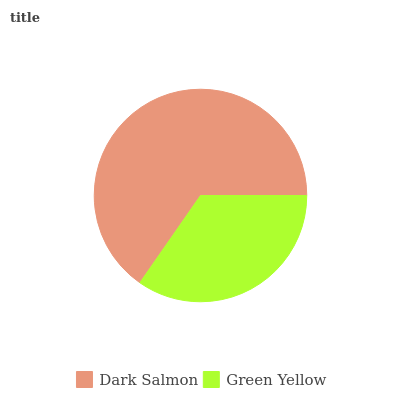Is Green Yellow the minimum?
Answer yes or no. Yes. Is Dark Salmon the maximum?
Answer yes or no. Yes. Is Green Yellow the maximum?
Answer yes or no. No. Is Dark Salmon greater than Green Yellow?
Answer yes or no. Yes. Is Green Yellow less than Dark Salmon?
Answer yes or no. Yes. Is Green Yellow greater than Dark Salmon?
Answer yes or no. No. Is Dark Salmon less than Green Yellow?
Answer yes or no. No. Is Dark Salmon the high median?
Answer yes or no. Yes. Is Green Yellow the low median?
Answer yes or no. Yes. Is Green Yellow the high median?
Answer yes or no. No. Is Dark Salmon the low median?
Answer yes or no. No. 